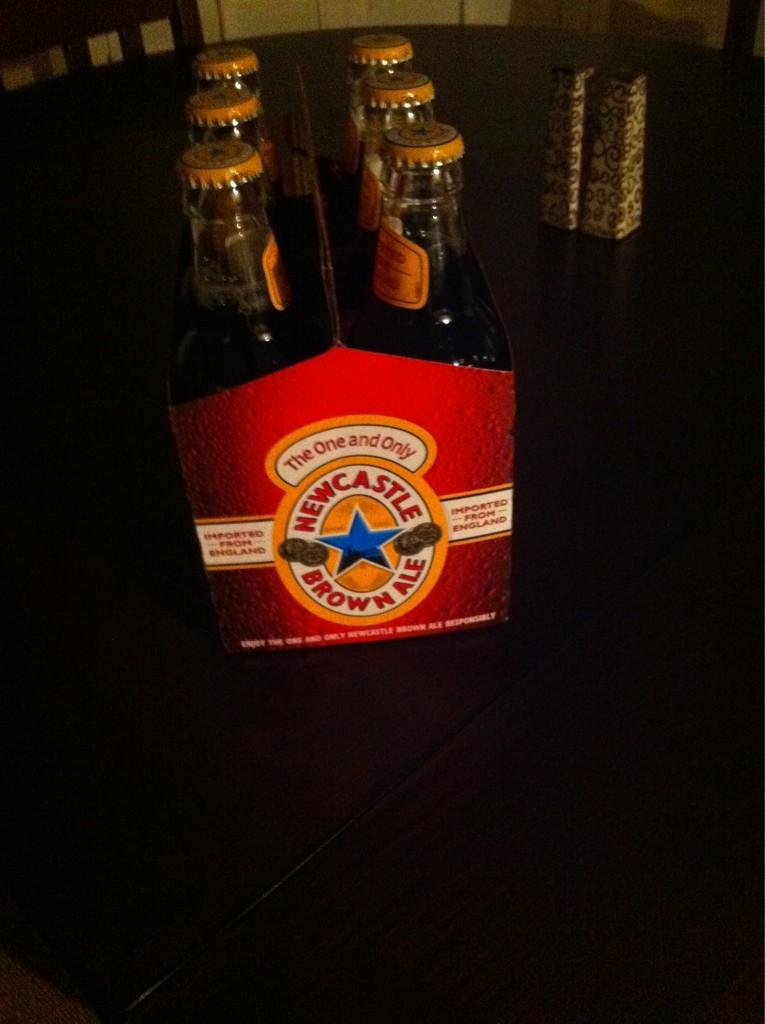What objects are on the table in the image? There are bottles on a table in the image. What can be seen on the left side of the image? There is a chair on the left side of the image. What is the color of the table in the image? The table is brown. Can you see any toes sticking out of the stocking in the image? There is no stocking or toe present in the image. 